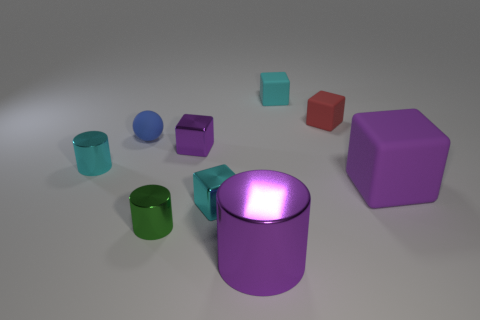Subtract all small cyan matte cubes. How many cubes are left? 4 Subtract all cyan cylinders. How many cylinders are left? 2 Subtract all cubes. How many objects are left? 4 Add 1 tiny green cylinders. How many objects exist? 10 Subtract all red cubes. Subtract all yellow balls. How many cubes are left? 4 Subtract all red blocks. How many blue cylinders are left? 0 Subtract all small metal things. Subtract all metallic cylinders. How many objects are left? 2 Add 4 purple objects. How many purple objects are left? 7 Add 5 tiny matte cubes. How many tiny matte cubes exist? 7 Subtract 0 yellow spheres. How many objects are left? 9 